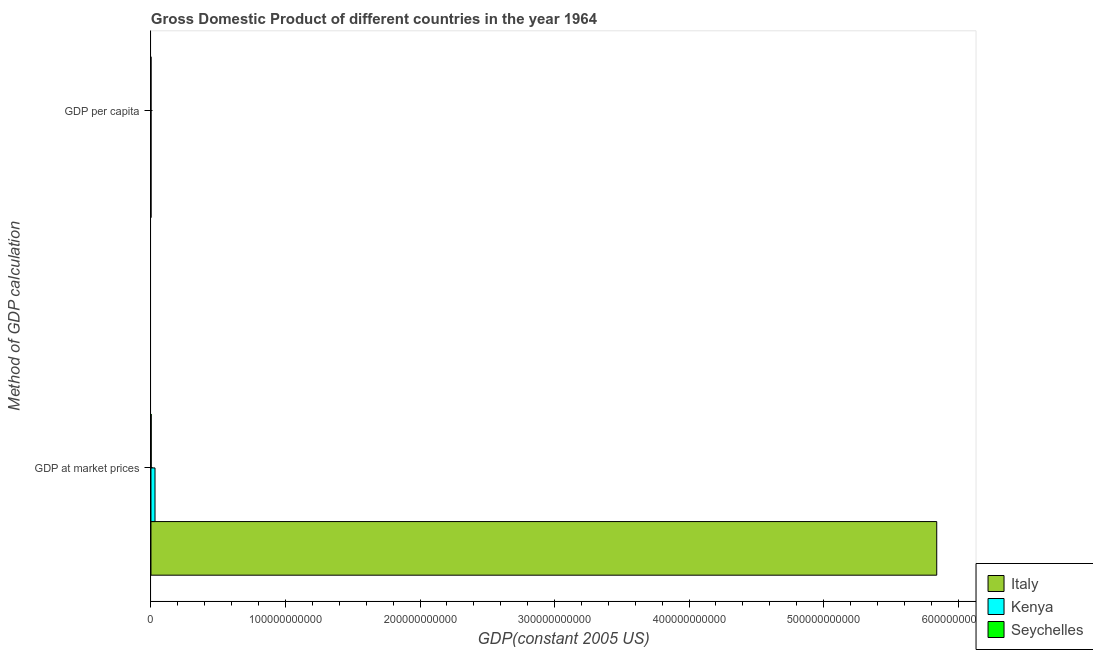How many different coloured bars are there?
Make the answer very short. 3. Are the number of bars per tick equal to the number of legend labels?
Offer a terse response. Yes. Are the number of bars on each tick of the Y-axis equal?
Make the answer very short. Yes. How many bars are there on the 2nd tick from the top?
Your response must be concise. 3. How many bars are there on the 2nd tick from the bottom?
Your answer should be very brief. 3. What is the label of the 2nd group of bars from the top?
Make the answer very short. GDP at market prices. What is the gdp at market prices in Kenya?
Your response must be concise. 3.01e+09. Across all countries, what is the maximum gdp at market prices?
Ensure brevity in your answer.  5.84e+11. Across all countries, what is the minimum gdp at market prices?
Make the answer very short. 1.67e+08. In which country was the gdp at market prices maximum?
Offer a terse response. Italy. In which country was the gdp at market prices minimum?
Offer a very short reply. Seychelles. What is the total gdp at market prices in the graph?
Ensure brevity in your answer.  5.87e+11. What is the difference between the gdp at market prices in Kenya and that in Seychelles?
Make the answer very short. 2.84e+09. What is the difference between the gdp at market prices in Italy and the gdp per capita in Seychelles?
Offer a terse response. 5.84e+11. What is the average gdp at market prices per country?
Provide a short and direct response. 1.96e+11. What is the difference between the gdp at market prices and gdp per capita in Italy?
Provide a succinct answer. 5.84e+11. What is the ratio of the gdp at market prices in Kenya to that in Italy?
Provide a succinct answer. 0.01. What does the 3rd bar from the top in GDP per capita represents?
Provide a short and direct response. Italy. What does the 2nd bar from the bottom in GDP at market prices represents?
Your answer should be very brief. Kenya. Are all the bars in the graph horizontal?
Your answer should be very brief. Yes. What is the difference between two consecutive major ticks on the X-axis?
Your answer should be compact. 1.00e+11. Does the graph contain any zero values?
Give a very brief answer. No. How many legend labels are there?
Your response must be concise. 3. How are the legend labels stacked?
Ensure brevity in your answer.  Vertical. What is the title of the graph?
Provide a short and direct response. Gross Domestic Product of different countries in the year 1964. Does "Sint Maarten (Dutch part)" appear as one of the legend labels in the graph?
Keep it short and to the point. No. What is the label or title of the X-axis?
Offer a very short reply. GDP(constant 2005 US). What is the label or title of the Y-axis?
Your answer should be very brief. Method of GDP calculation. What is the GDP(constant 2005 US) in Italy in GDP at market prices?
Your answer should be compact. 5.84e+11. What is the GDP(constant 2005 US) of Kenya in GDP at market prices?
Offer a terse response. 3.01e+09. What is the GDP(constant 2005 US) in Seychelles in GDP at market prices?
Your response must be concise. 1.67e+08. What is the GDP(constant 2005 US) in Italy in GDP per capita?
Keep it short and to the point. 1.13e+04. What is the GDP(constant 2005 US) of Kenya in GDP per capita?
Provide a short and direct response. 327.08. What is the GDP(constant 2005 US) in Seychelles in GDP per capita?
Give a very brief answer. 3596.61. Across all Method of GDP calculation, what is the maximum GDP(constant 2005 US) of Italy?
Offer a terse response. 5.84e+11. Across all Method of GDP calculation, what is the maximum GDP(constant 2005 US) of Kenya?
Your answer should be very brief. 3.01e+09. Across all Method of GDP calculation, what is the maximum GDP(constant 2005 US) of Seychelles?
Offer a very short reply. 1.67e+08. Across all Method of GDP calculation, what is the minimum GDP(constant 2005 US) in Italy?
Provide a succinct answer. 1.13e+04. Across all Method of GDP calculation, what is the minimum GDP(constant 2005 US) in Kenya?
Your response must be concise. 327.08. Across all Method of GDP calculation, what is the minimum GDP(constant 2005 US) of Seychelles?
Provide a succinct answer. 3596.61. What is the total GDP(constant 2005 US) in Italy in the graph?
Your answer should be very brief. 5.84e+11. What is the total GDP(constant 2005 US) in Kenya in the graph?
Keep it short and to the point. 3.01e+09. What is the total GDP(constant 2005 US) in Seychelles in the graph?
Your answer should be compact. 1.67e+08. What is the difference between the GDP(constant 2005 US) of Italy in GDP at market prices and that in GDP per capita?
Your answer should be very brief. 5.84e+11. What is the difference between the GDP(constant 2005 US) of Kenya in GDP at market prices and that in GDP per capita?
Offer a very short reply. 3.01e+09. What is the difference between the GDP(constant 2005 US) of Seychelles in GDP at market prices and that in GDP per capita?
Your answer should be very brief. 1.67e+08. What is the difference between the GDP(constant 2005 US) of Italy in GDP at market prices and the GDP(constant 2005 US) of Kenya in GDP per capita?
Provide a short and direct response. 5.84e+11. What is the difference between the GDP(constant 2005 US) in Italy in GDP at market prices and the GDP(constant 2005 US) in Seychelles in GDP per capita?
Your response must be concise. 5.84e+11. What is the difference between the GDP(constant 2005 US) of Kenya in GDP at market prices and the GDP(constant 2005 US) of Seychelles in GDP per capita?
Your answer should be compact. 3.01e+09. What is the average GDP(constant 2005 US) of Italy per Method of GDP calculation?
Your response must be concise. 2.92e+11. What is the average GDP(constant 2005 US) of Kenya per Method of GDP calculation?
Provide a short and direct response. 1.50e+09. What is the average GDP(constant 2005 US) in Seychelles per Method of GDP calculation?
Offer a terse response. 8.33e+07. What is the difference between the GDP(constant 2005 US) of Italy and GDP(constant 2005 US) of Kenya in GDP at market prices?
Provide a short and direct response. 5.81e+11. What is the difference between the GDP(constant 2005 US) of Italy and GDP(constant 2005 US) of Seychelles in GDP at market prices?
Make the answer very short. 5.84e+11. What is the difference between the GDP(constant 2005 US) in Kenya and GDP(constant 2005 US) in Seychelles in GDP at market prices?
Give a very brief answer. 2.84e+09. What is the difference between the GDP(constant 2005 US) of Italy and GDP(constant 2005 US) of Kenya in GDP per capita?
Provide a succinct answer. 1.10e+04. What is the difference between the GDP(constant 2005 US) of Italy and GDP(constant 2005 US) of Seychelles in GDP per capita?
Offer a terse response. 7707.26. What is the difference between the GDP(constant 2005 US) in Kenya and GDP(constant 2005 US) in Seychelles in GDP per capita?
Provide a succinct answer. -3269.53. What is the ratio of the GDP(constant 2005 US) in Italy in GDP at market prices to that in GDP per capita?
Provide a succinct answer. 5.17e+07. What is the ratio of the GDP(constant 2005 US) of Kenya in GDP at market prices to that in GDP per capita?
Your answer should be compact. 9.20e+06. What is the ratio of the GDP(constant 2005 US) in Seychelles in GDP at market prices to that in GDP per capita?
Offer a very short reply. 4.63e+04. What is the difference between the highest and the second highest GDP(constant 2005 US) of Italy?
Make the answer very short. 5.84e+11. What is the difference between the highest and the second highest GDP(constant 2005 US) of Kenya?
Offer a very short reply. 3.01e+09. What is the difference between the highest and the second highest GDP(constant 2005 US) in Seychelles?
Provide a succinct answer. 1.67e+08. What is the difference between the highest and the lowest GDP(constant 2005 US) in Italy?
Offer a terse response. 5.84e+11. What is the difference between the highest and the lowest GDP(constant 2005 US) of Kenya?
Offer a very short reply. 3.01e+09. What is the difference between the highest and the lowest GDP(constant 2005 US) of Seychelles?
Provide a short and direct response. 1.67e+08. 